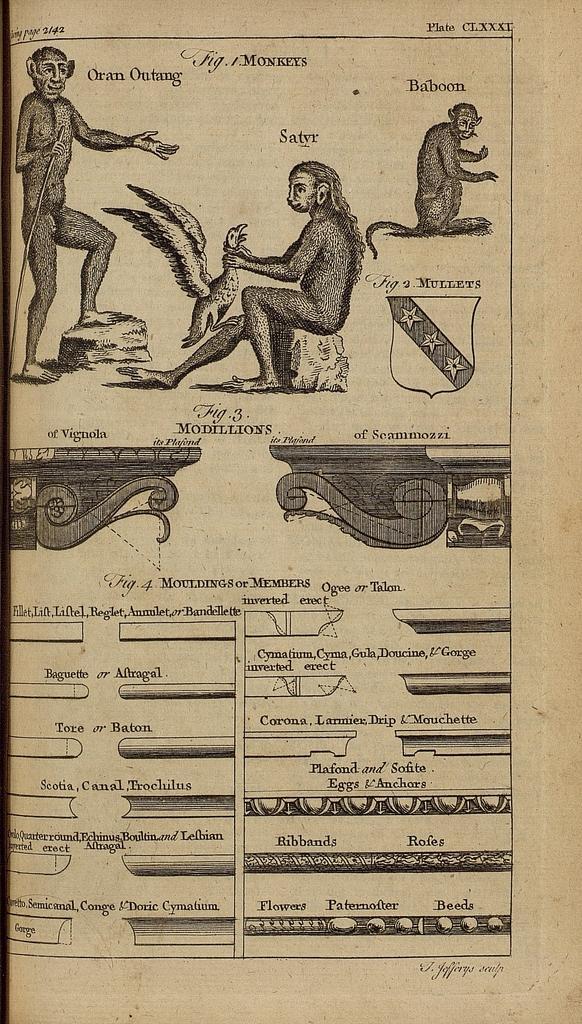How would you summarize this image in a sentence or two? In this picture there is a poster. At the top of the poster I can see the monkey and person who was holding a bird. Beside him there is a man who is standing on the stone and holding a stick. 